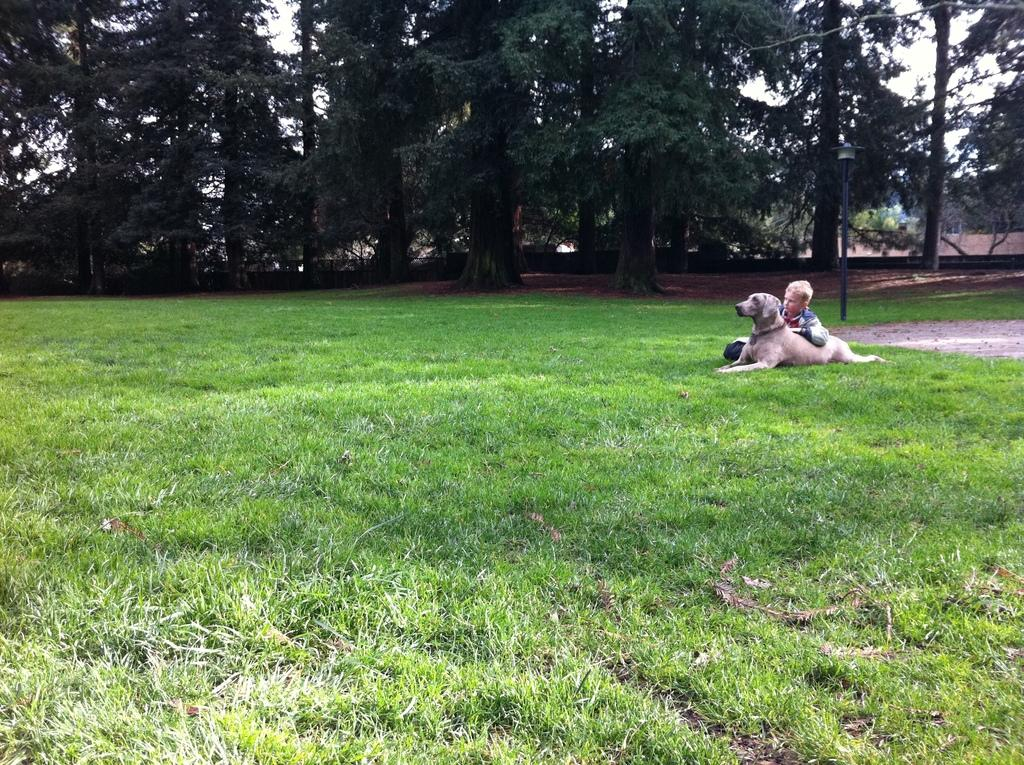What type of animal is in the image? There is a dog in the image. Who else is in the image besides the dog? There is a boy in the image. What are the boy and dog doing in the image? The boy and dog are laying on the grass. What can be seen in the background of the image? There are trees visible in the background of the image. What type of business is being conducted in the image? There is no indication of any business being conducted in the image; it features a boy and a dog laying on the grass. 